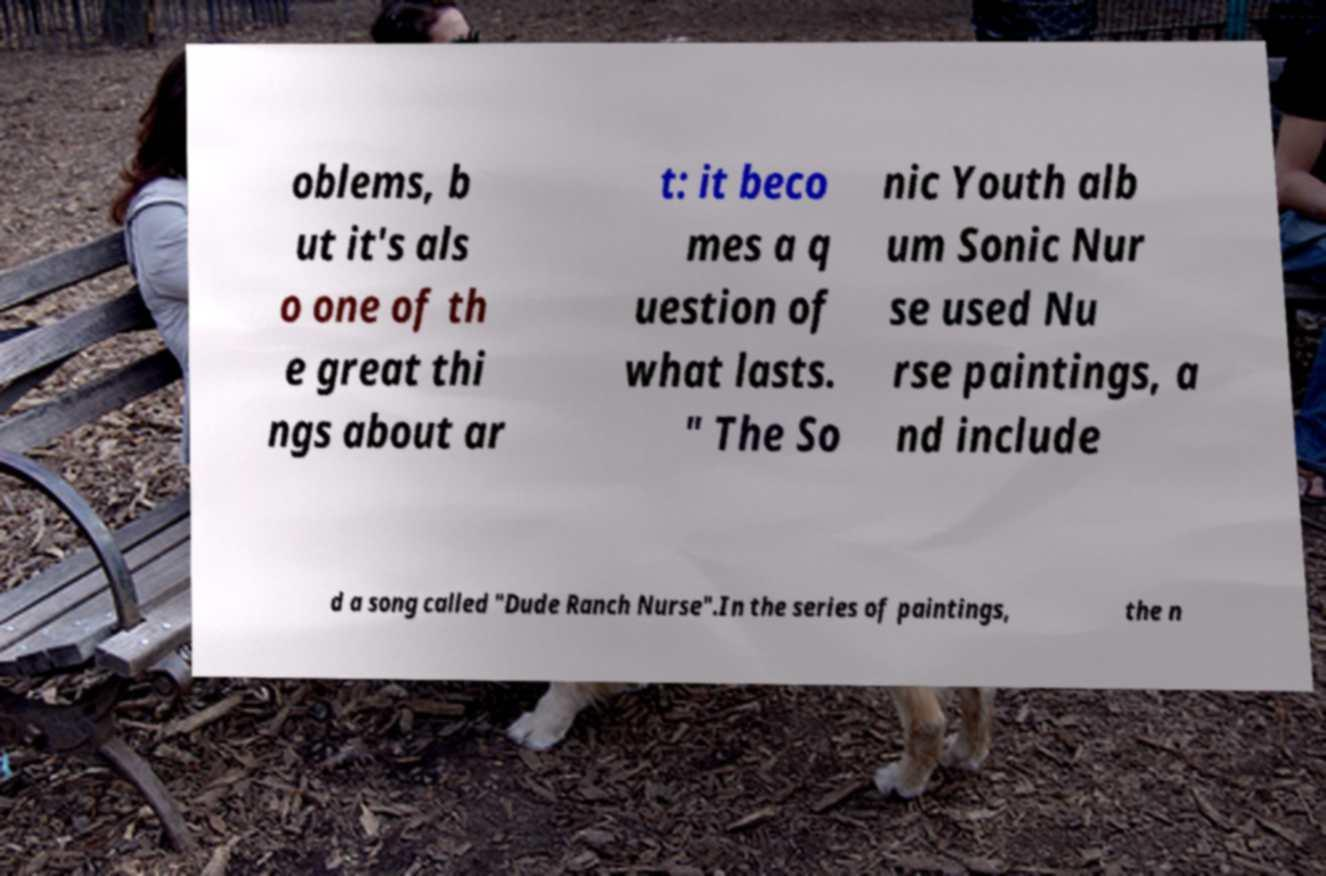Could you extract and type out the text from this image? oblems, b ut it's als o one of th e great thi ngs about ar t: it beco mes a q uestion of what lasts. " The So nic Youth alb um Sonic Nur se used Nu rse paintings, a nd include d a song called "Dude Ranch Nurse".In the series of paintings, the n 